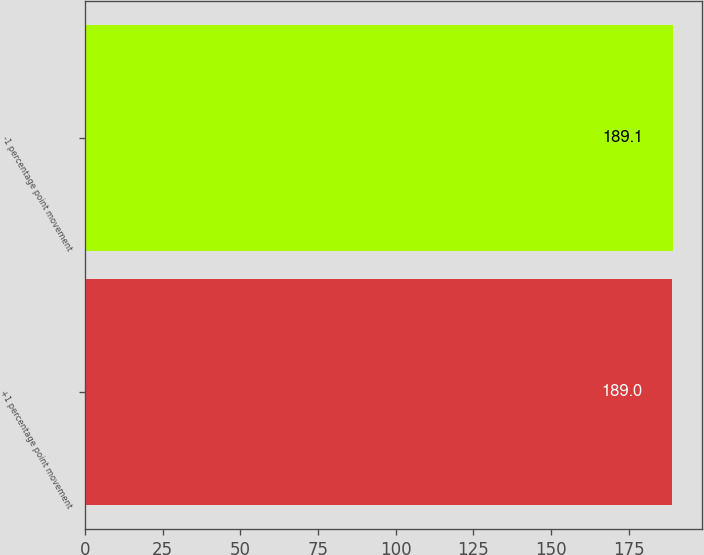Convert chart. <chart><loc_0><loc_0><loc_500><loc_500><bar_chart><fcel>+1 percentage point movement<fcel>-1 percentage point movement<nl><fcel>189<fcel>189.1<nl></chart> 